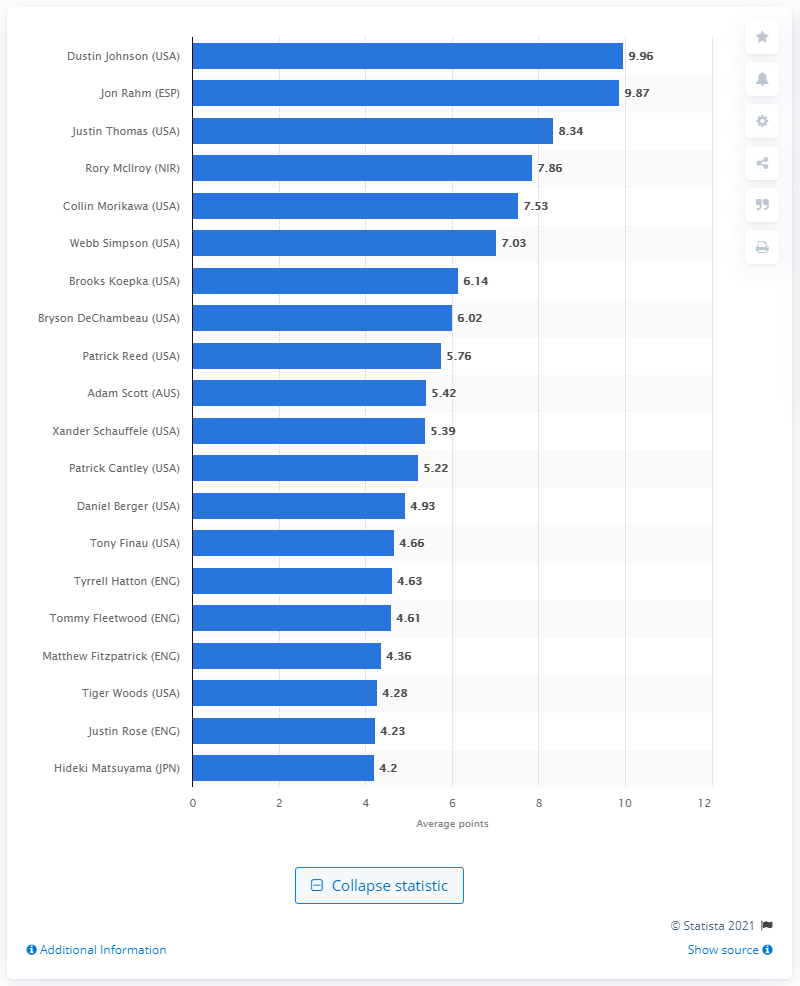List a handful of essential elements in this visual. As of August 2020, Dustin Johnson's average score was 9.96. 